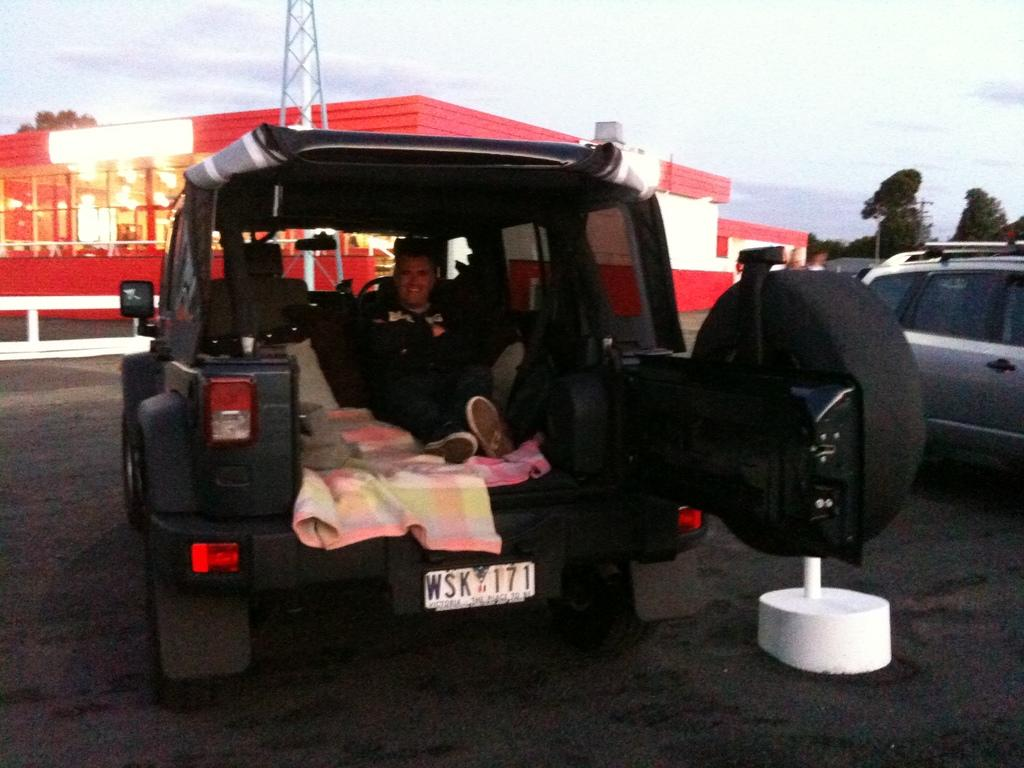What is on the road in the image? There is a vehicle on the road in the image. Who is inside the vehicle? A person is sitting in the vehicle and smiling. What is in front of the vehicle? There is a building in front of the vehicle. What can be seen above the vehicle? The sky is visible above the vehicle. What type of business is being conducted in the vehicle? A: There is no indication of any business being conducted in the vehicle; the person is simply sitting and smiling. 